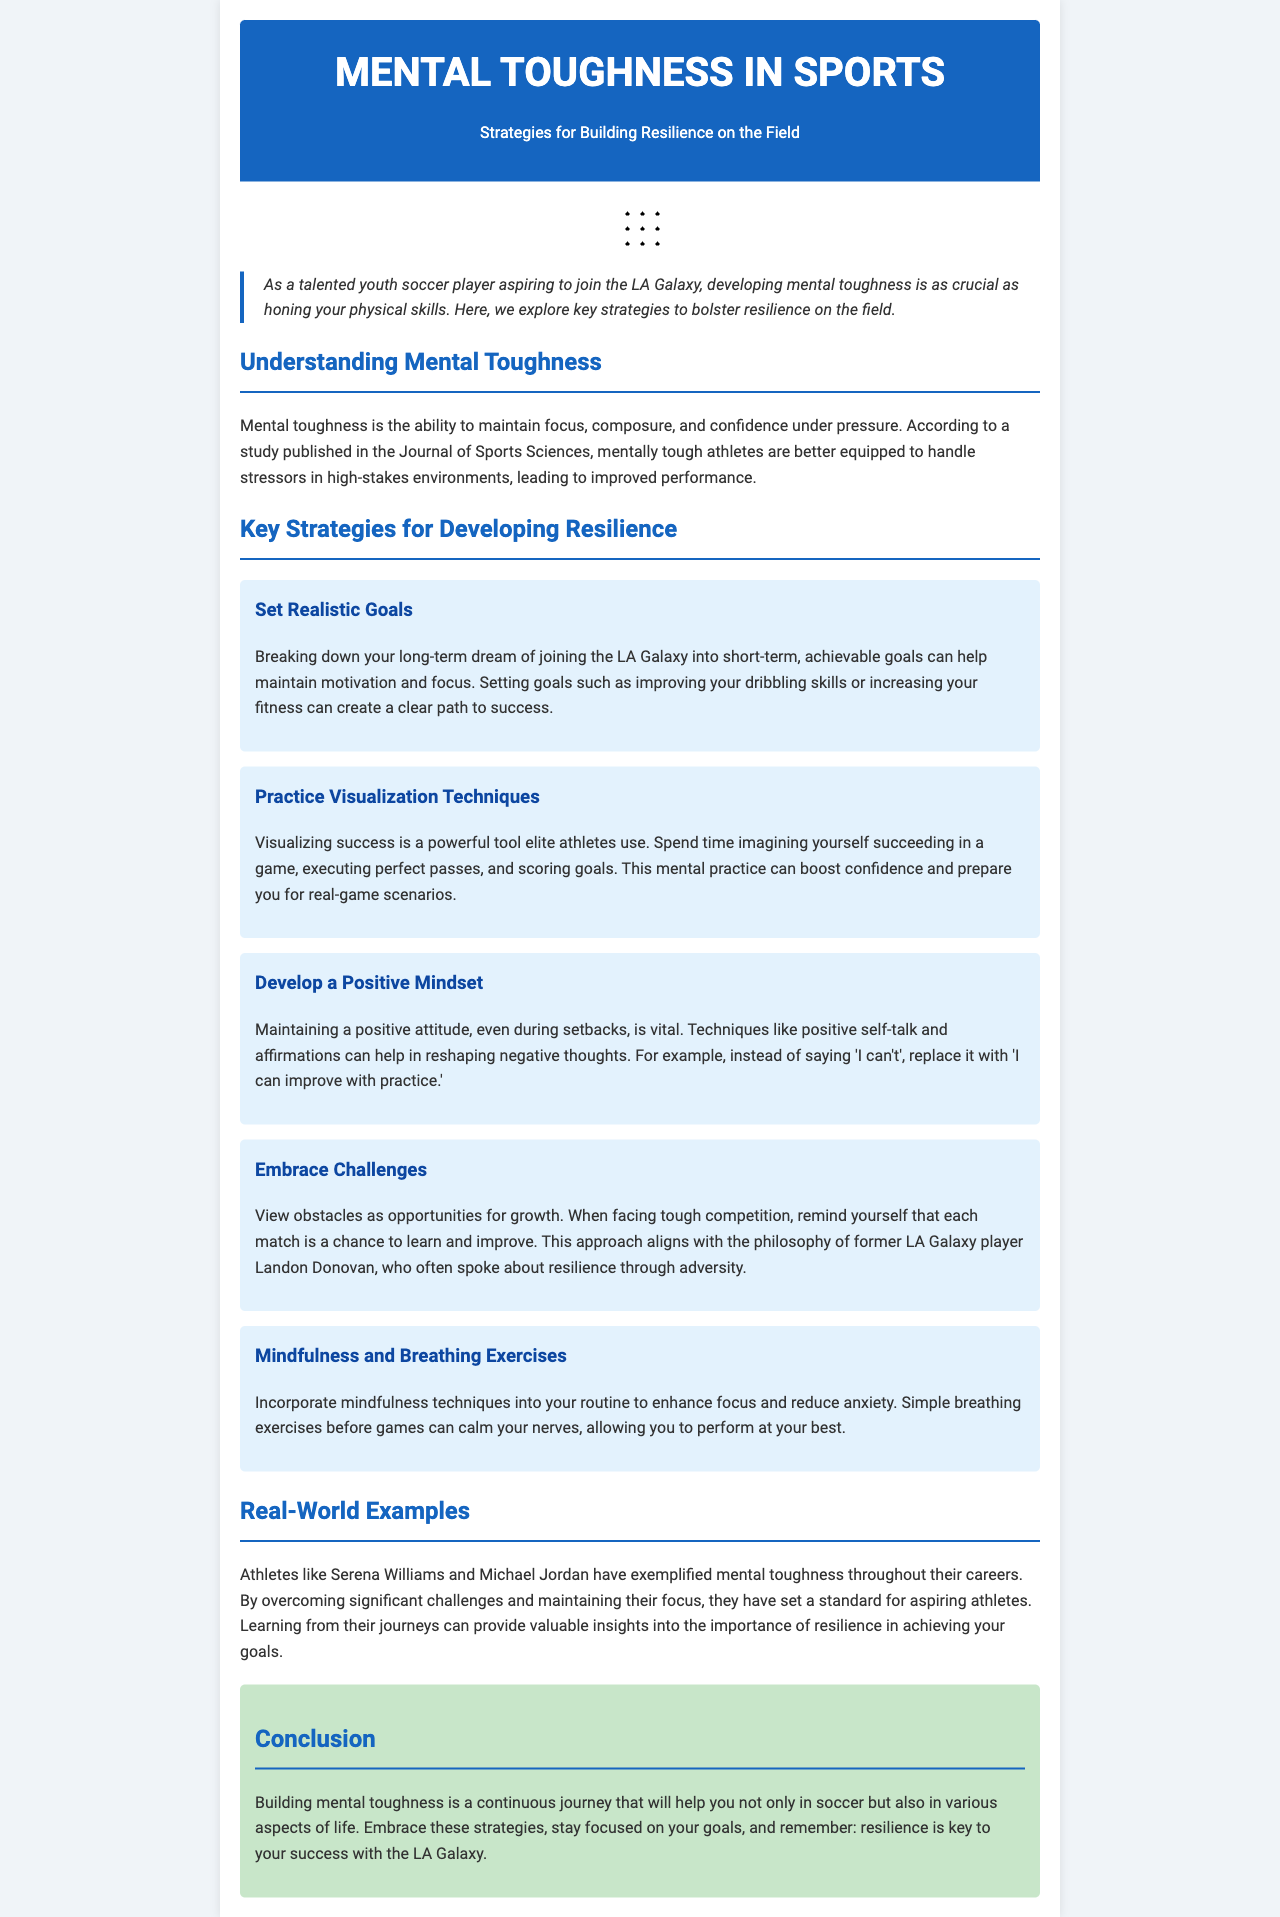what is the title of the newsletter? The title of the newsletter is the main heading of the document and reflects its theme.
Answer: Mental Toughness in Sports what is defined as mental toughness? Mental toughness is defined in the document as the ability to maintain focus, composure, and confidence under pressure.
Answer: the ability to maintain focus, composure, and confidence under pressure how many key strategies for developing resilience are listed? The document lists several strategies for resilience, which can be counted in the section titled "Key Strategies for Developing Resilience."
Answer: five what technique involves visualizing success? One of the strategies mentioned for enhancing performance involves visualizing.
Answer: Practice Visualization Techniques who is mentioned as a former player that emphasized resilience? The document mentions a specific player whose philosophy aligns with resilience.
Answer: Landon Donovan what mindset should an athlete develop according to the document? The document emphasizes the importance of a specific type of mindset to sustain positivity.
Answer: Positive Mindset what is one benefit of mindfulness techniques? Mindfulness techniques can provide a specific benefit related to performance and nerves, as stated in the document.
Answer: enhance focus and reduce anxiety what should athletes view obstacles as? According to the document, obstacles should be perceived in a specific way that encourages growth.
Answer: opportunities for growth 